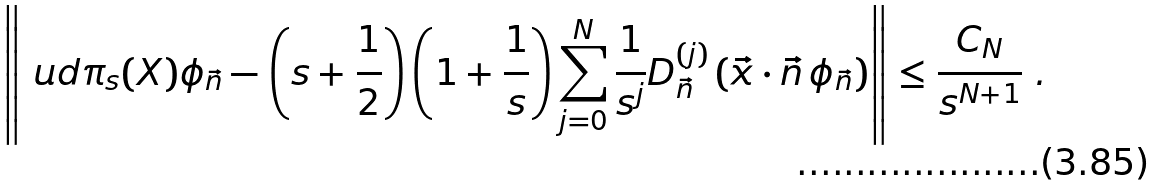Convert formula to latex. <formula><loc_0><loc_0><loc_500><loc_500>\left \| \ u d \pi _ { s } ( X ) \phi _ { \vec { n } } - \left ( s + \frac { 1 } { 2 } \right ) \left ( 1 + \frac { 1 } { s } \right ) \sum _ { j = 0 } ^ { N } \frac { 1 } { s ^ { j } } D ^ { ( j ) } _ { \vec { n } } \left ( \vec { x } \cdot \vec { n } \, \phi _ { \vec { n } } \right ) \right \| \leq \frac { C _ { N } } { s ^ { N + 1 } } \ .</formula> 